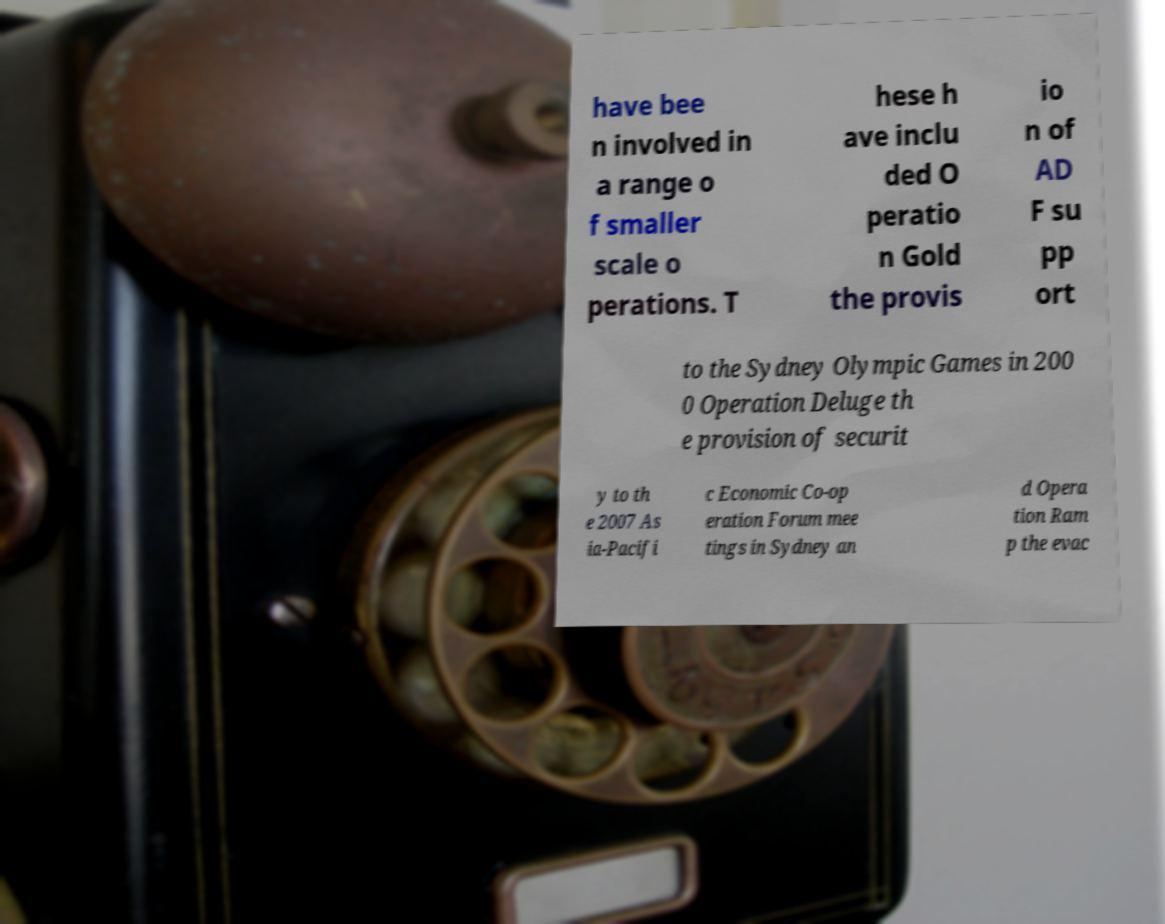For documentation purposes, I need the text within this image transcribed. Could you provide that? have bee n involved in a range o f smaller scale o perations. T hese h ave inclu ded O peratio n Gold the provis io n of AD F su pp ort to the Sydney Olympic Games in 200 0 Operation Deluge th e provision of securit y to th e 2007 As ia-Pacifi c Economic Co-op eration Forum mee tings in Sydney an d Opera tion Ram p the evac 